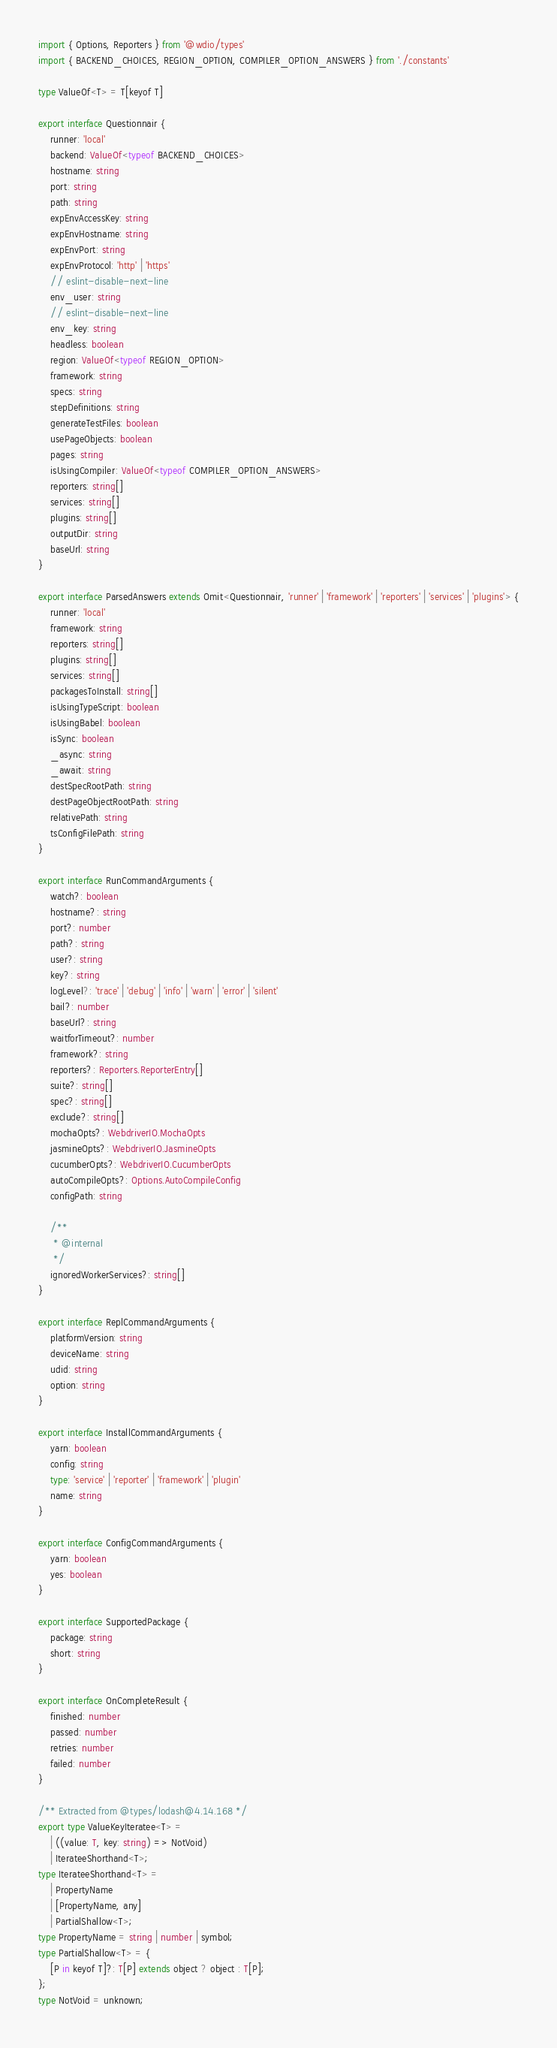Convert code to text. <code><loc_0><loc_0><loc_500><loc_500><_TypeScript_>import { Options, Reporters } from '@wdio/types'
import { BACKEND_CHOICES, REGION_OPTION, COMPILER_OPTION_ANSWERS } from './constants'

type ValueOf<T> = T[keyof T]

export interface Questionnair {
    runner: 'local'
    backend: ValueOf<typeof BACKEND_CHOICES>
    hostname: string
    port: string
    path: string
    expEnvAccessKey: string
    expEnvHostname: string
    expEnvPort: string
    expEnvProtocol: 'http' | 'https'
    // eslint-disable-next-line
    env_user: string
    // eslint-disable-next-line
    env_key: string
    headless: boolean
    region: ValueOf<typeof REGION_OPTION>
    framework: string
    specs: string
    stepDefinitions: string
    generateTestFiles: boolean
    usePageObjects: boolean
    pages: string
    isUsingCompiler: ValueOf<typeof COMPILER_OPTION_ANSWERS>
    reporters: string[]
    services: string[]
    plugins: string[]
    outputDir: string
    baseUrl: string
}

export interface ParsedAnswers extends Omit<Questionnair, 'runner' | 'framework' | 'reporters' | 'services' | 'plugins'> {
    runner: 'local'
    framework: string
    reporters: string[]
    plugins: string[]
    services: string[]
    packagesToInstall: string[]
    isUsingTypeScript: boolean
    isUsingBabel: boolean
    isSync: boolean
    _async: string
    _await: string
    destSpecRootPath: string
    destPageObjectRootPath: string
    relativePath: string
    tsConfigFilePath: string
}

export interface RunCommandArguments {
    watch?: boolean
    hostname?: string
    port?: number
    path?: string
    user?: string
    key?: string
    logLevel?: 'trace' | 'debug' | 'info' | 'warn' | 'error' | 'silent'
    bail?: number
    baseUrl?: string
    waitforTimeout?: number
    framework?: string
    reporters?: Reporters.ReporterEntry[]
    suite?: string[]
    spec?: string[]
    exclude?: string[]
    mochaOpts?: WebdriverIO.MochaOpts
    jasmineOpts?: WebdriverIO.JasmineOpts
    cucumberOpts?: WebdriverIO.CucumberOpts
    autoCompileOpts?: Options.AutoCompileConfig
    configPath: string

    /**
     * @internal
     */
    ignoredWorkerServices?: string[]
}

export interface ReplCommandArguments {
    platformVersion: string
    deviceName: string
    udid: string
    option: string
}

export interface InstallCommandArguments {
    yarn: boolean
    config: string
    type: 'service' | 'reporter' | 'framework' | 'plugin'
    name: string
}

export interface ConfigCommandArguments {
    yarn: boolean
    yes: boolean
}

export interface SupportedPackage {
    package: string
    short: string
}

export interface OnCompleteResult {
    finished: number
    passed: number
    retries: number
    failed: number
}

/** Extracted from @types/lodash@4.14.168 */
export type ValueKeyIteratee<T> =
    | ((value: T, key: string) => NotVoid)
    | IterateeShorthand<T>;
type IterateeShorthand<T> =
    | PropertyName
    | [PropertyName, any]
    | PartialShallow<T>;
type PropertyName = string | number | symbol;
type PartialShallow<T> = {
    [P in keyof T]?: T[P] extends object ? object : T[P];
};
type NotVoid = unknown;
</code> 